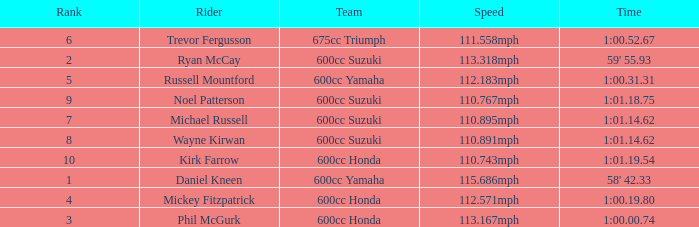How many ranks have michael russell as the rider? 7.0. 